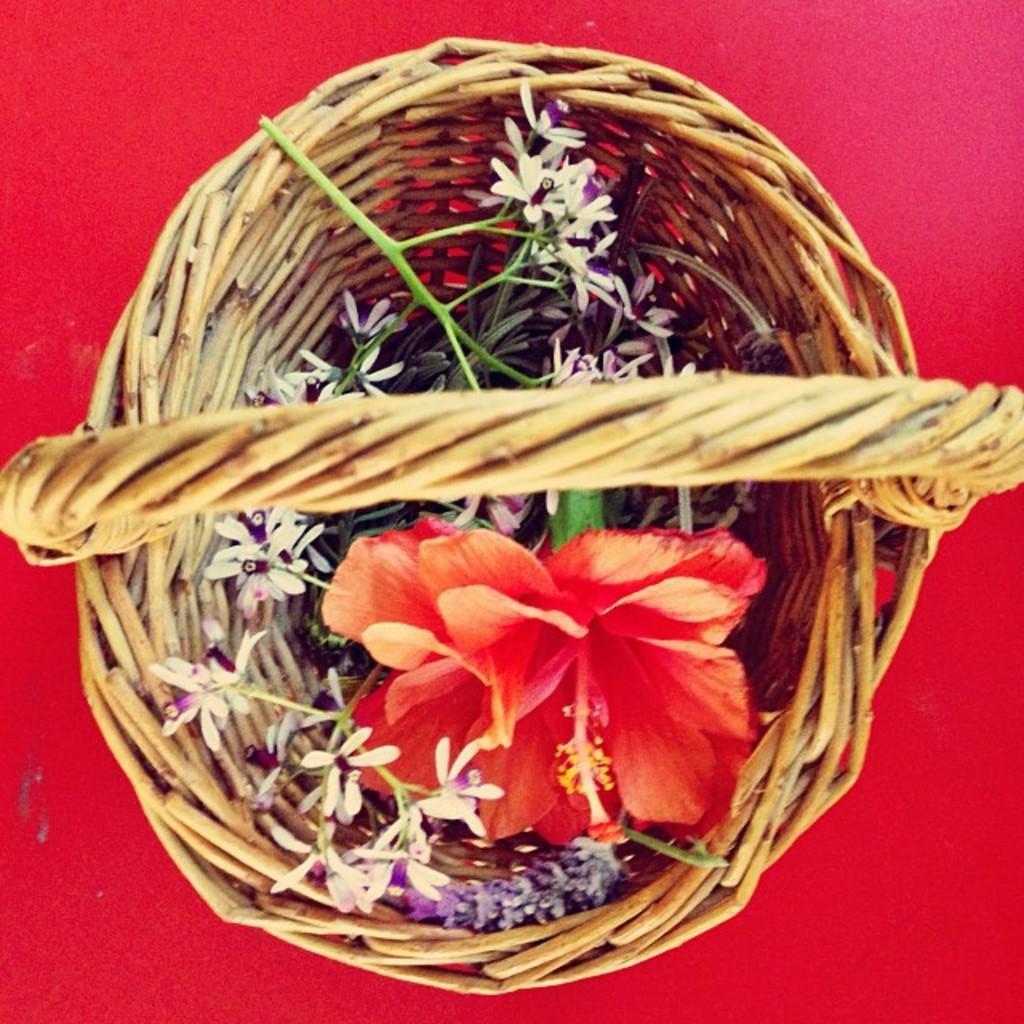Describe this image in one or two sentences. This picture consists of baskets , in the baskets I can see flowers. 